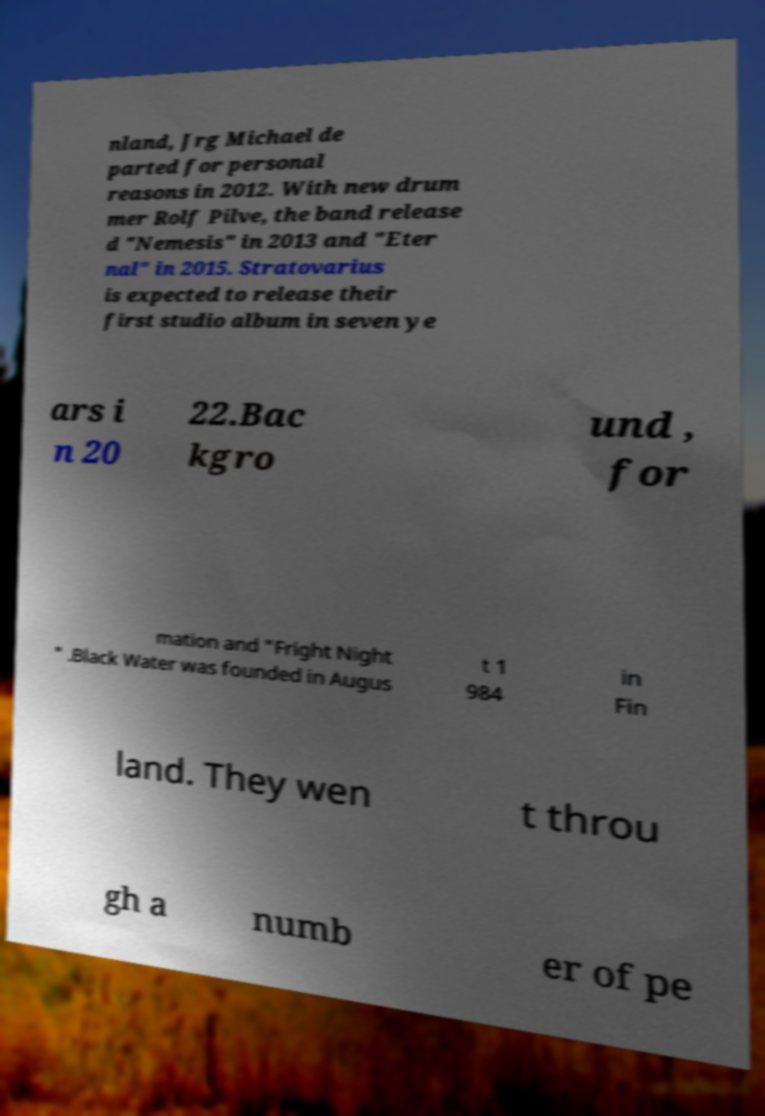There's text embedded in this image that I need extracted. Can you transcribe it verbatim? nland, Jrg Michael de parted for personal reasons in 2012. With new drum mer Rolf Pilve, the band release d "Nemesis" in 2013 and "Eter nal" in 2015. Stratovarius is expected to release their first studio album in seven ye ars i n 20 22.Bac kgro und , for mation and "Fright Night " .Black Water was founded in Augus t 1 984 in Fin land. They wen t throu gh a numb er of pe 